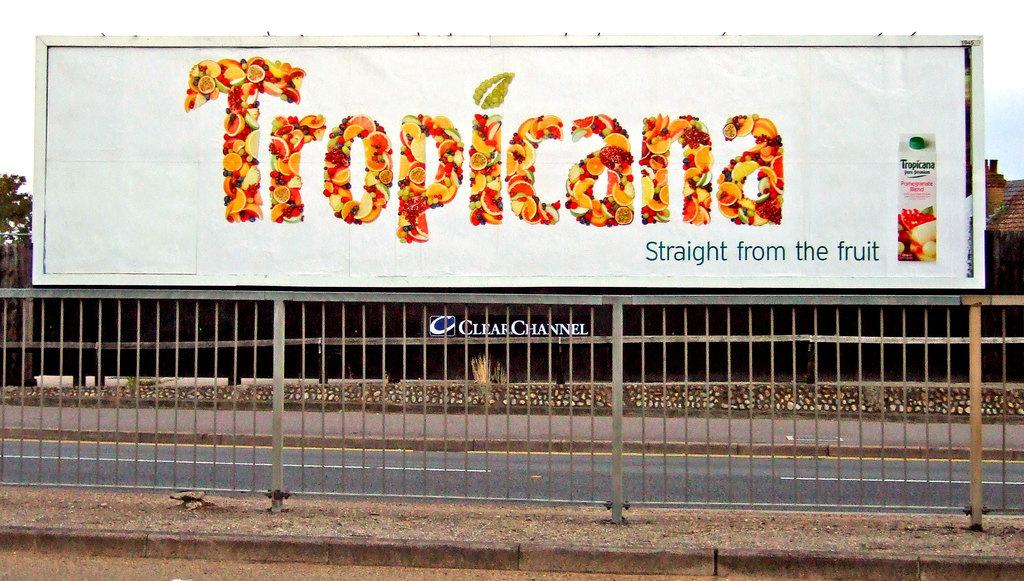Who makes this fruit juice?
Your response must be concise. Tropicana. 